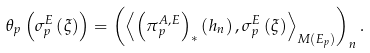<formula> <loc_0><loc_0><loc_500><loc_500>\theta _ { p } \left ( \sigma _ { p } ^ { E } \left ( \xi \right ) \right ) = \left ( \left \langle \left ( \pi _ { p } ^ { A , E } \right ) _ { \ast } \left ( h _ { n } \right ) , \sigma _ { p } ^ { E } \left ( \xi \right ) \right \rangle _ { M ( E _ { p } ) } \right ) _ { n } .</formula> 